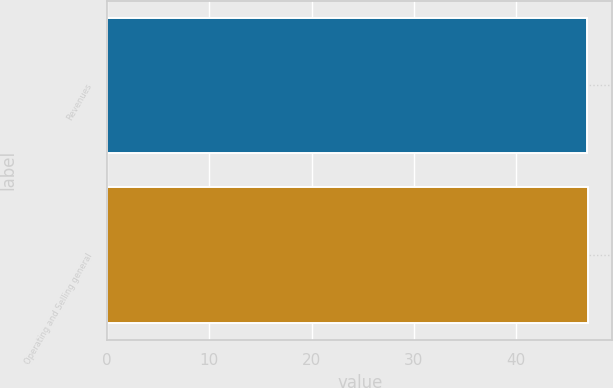Convert chart to OTSL. <chart><loc_0><loc_0><loc_500><loc_500><bar_chart><fcel>Revenues<fcel>Operating and Selling general<nl><fcel>47<fcel>47.1<nl></chart> 